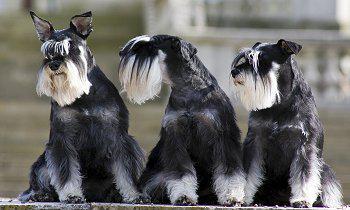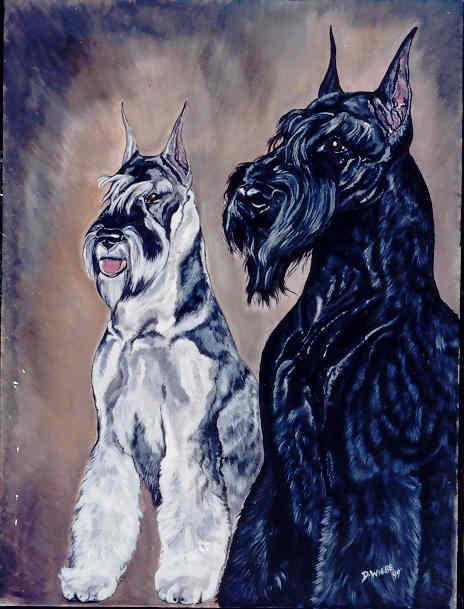The first image is the image on the left, the second image is the image on the right. Given the left and right images, does the statement "The left image contains at least three dogs." hold true? Answer yes or no. Yes. The first image is the image on the left, the second image is the image on the right. Evaluate the accuracy of this statement regarding the images: "The combined images contain five schnauzers, and at least four are sitting upright.". Is it true? Answer yes or no. Yes. 